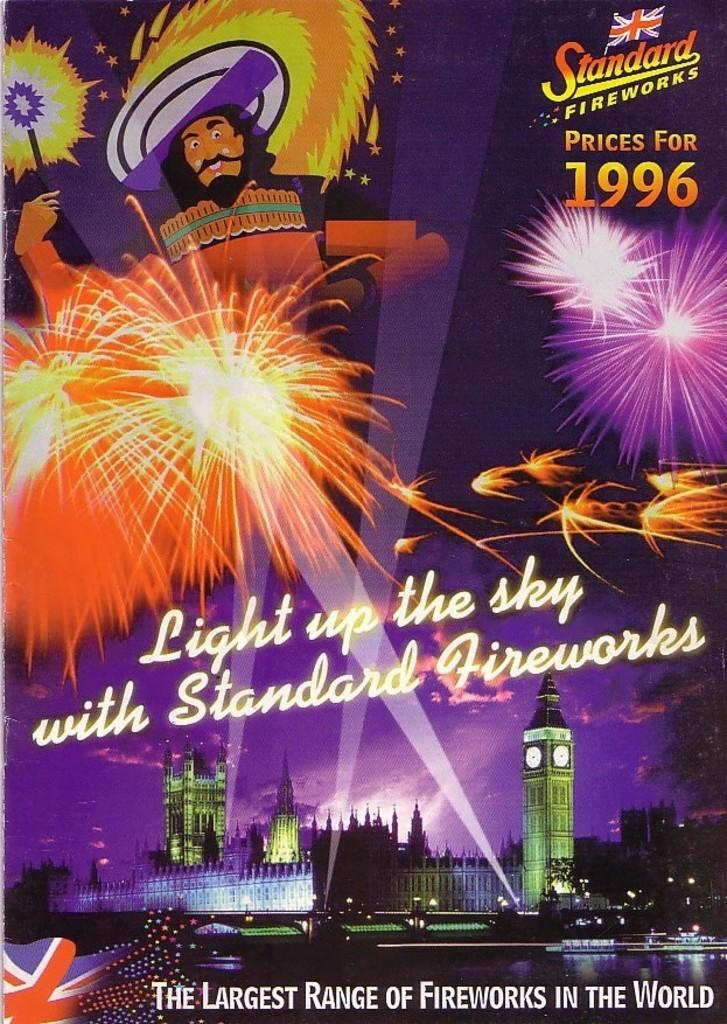<image>
Render a clear and concise summary of the photo. An advert for Standard Fireworks with reduced prices from 1996 